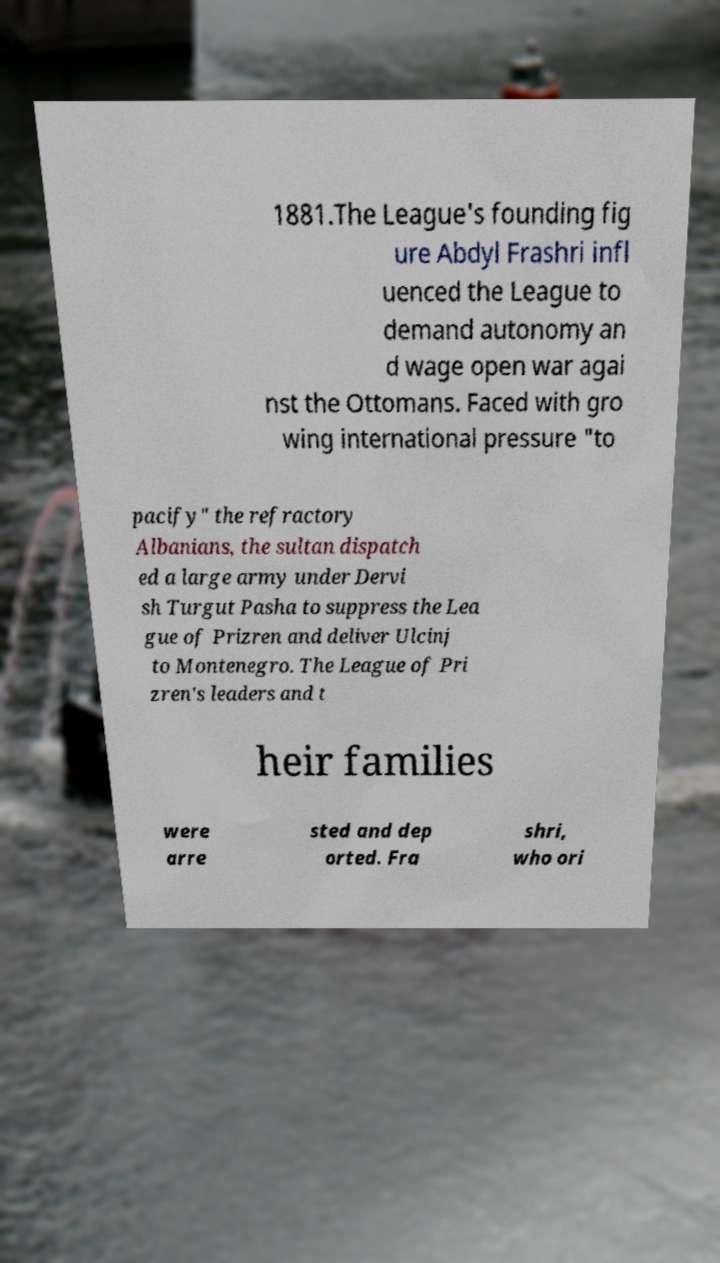Could you extract and type out the text from this image? 1881.The League's founding fig ure Abdyl Frashri infl uenced the League to demand autonomy an d wage open war agai nst the Ottomans. Faced with gro wing international pressure "to pacify" the refractory Albanians, the sultan dispatch ed a large army under Dervi sh Turgut Pasha to suppress the Lea gue of Prizren and deliver Ulcinj to Montenegro. The League of Pri zren's leaders and t heir families were arre sted and dep orted. Fra shri, who ori 